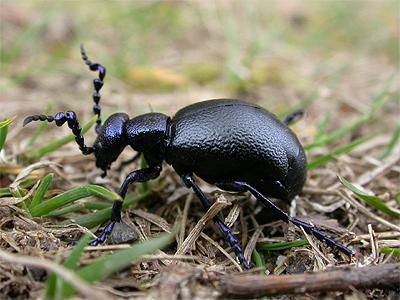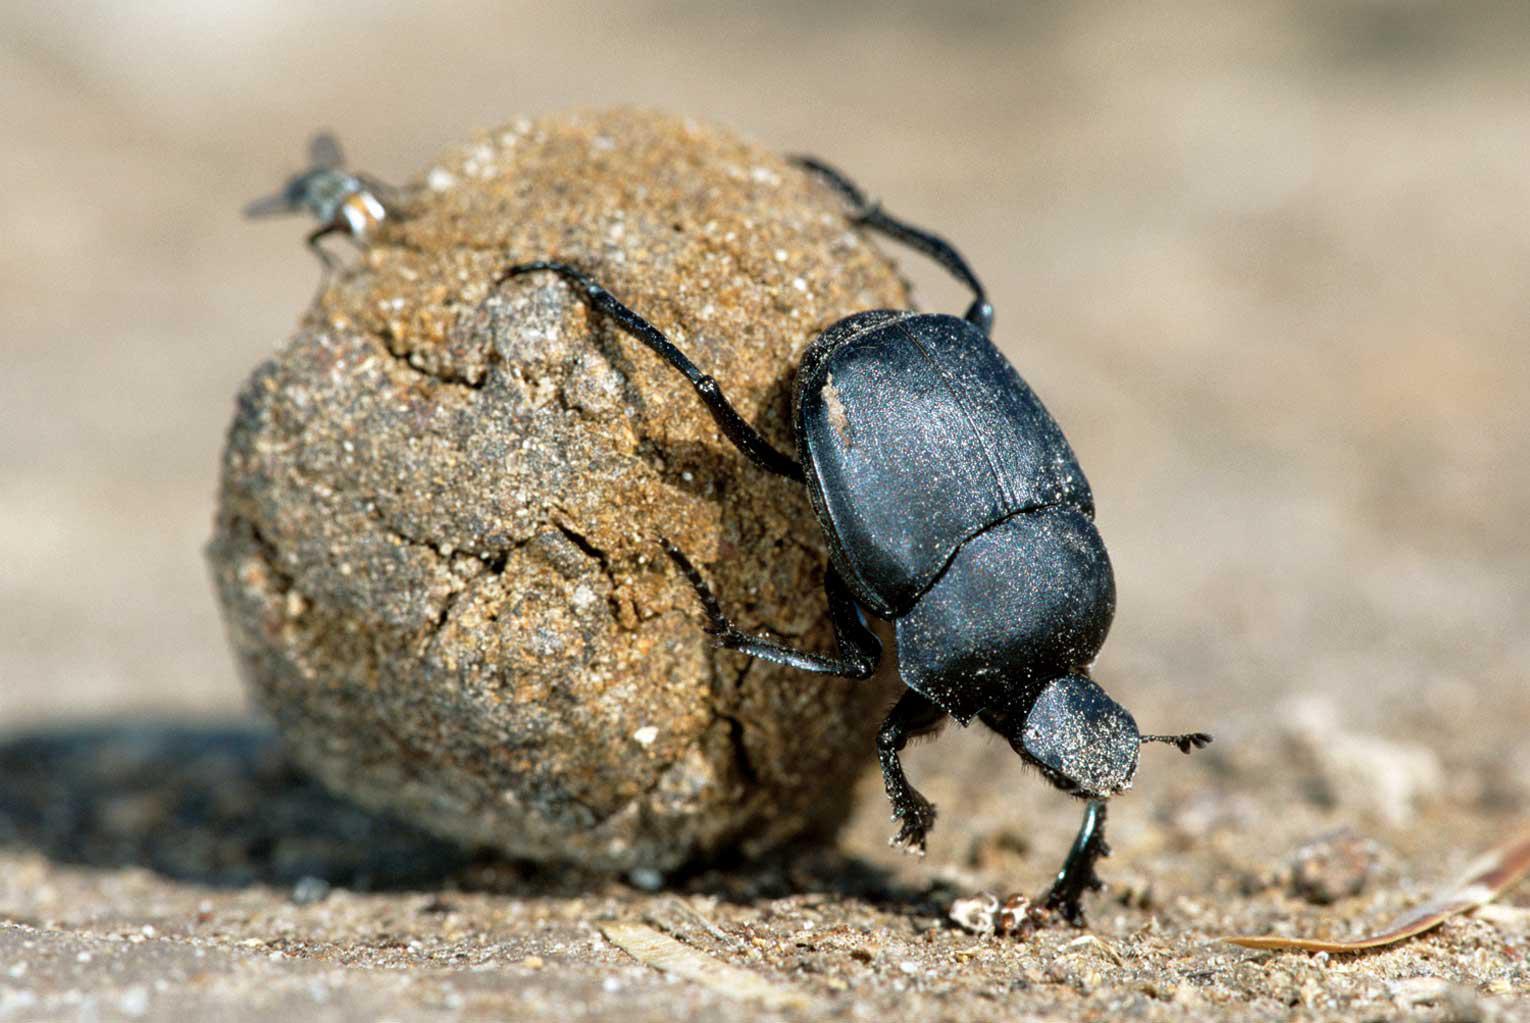The first image is the image on the left, the second image is the image on the right. Assess this claim about the two images: "A beetle with a shiny textured back is alone in an image without a dung ball shape.". Correct or not? Answer yes or no. Yes. The first image is the image on the left, the second image is the image on the right. Assess this claim about the two images: "Two beetles climb on a clod of dirt in the image on the left.". Correct or not? Answer yes or no. No. 